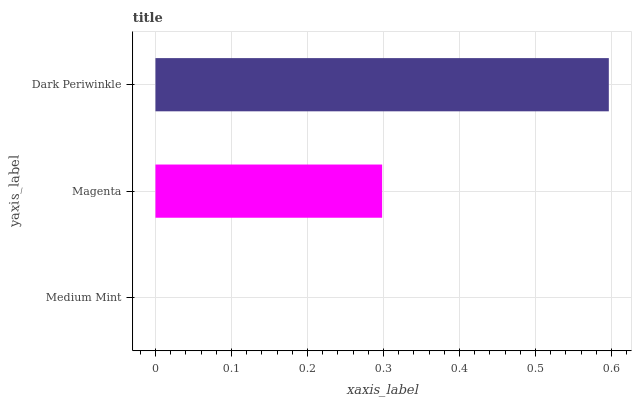Is Medium Mint the minimum?
Answer yes or no. Yes. Is Dark Periwinkle the maximum?
Answer yes or no. Yes. Is Magenta the minimum?
Answer yes or no. No. Is Magenta the maximum?
Answer yes or no. No. Is Magenta greater than Medium Mint?
Answer yes or no. Yes. Is Medium Mint less than Magenta?
Answer yes or no. Yes. Is Medium Mint greater than Magenta?
Answer yes or no. No. Is Magenta less than Medium Mint?
Answer yes or no. No. Is Magenta the high median?
Answer yes or no. Yes. Is Magenta the low median?
Answer yes or no. Yes. Is Medium Mint the high median?
Answer yes or no. No. Is Medium Mint the low median?
Answer yes or no. No. 